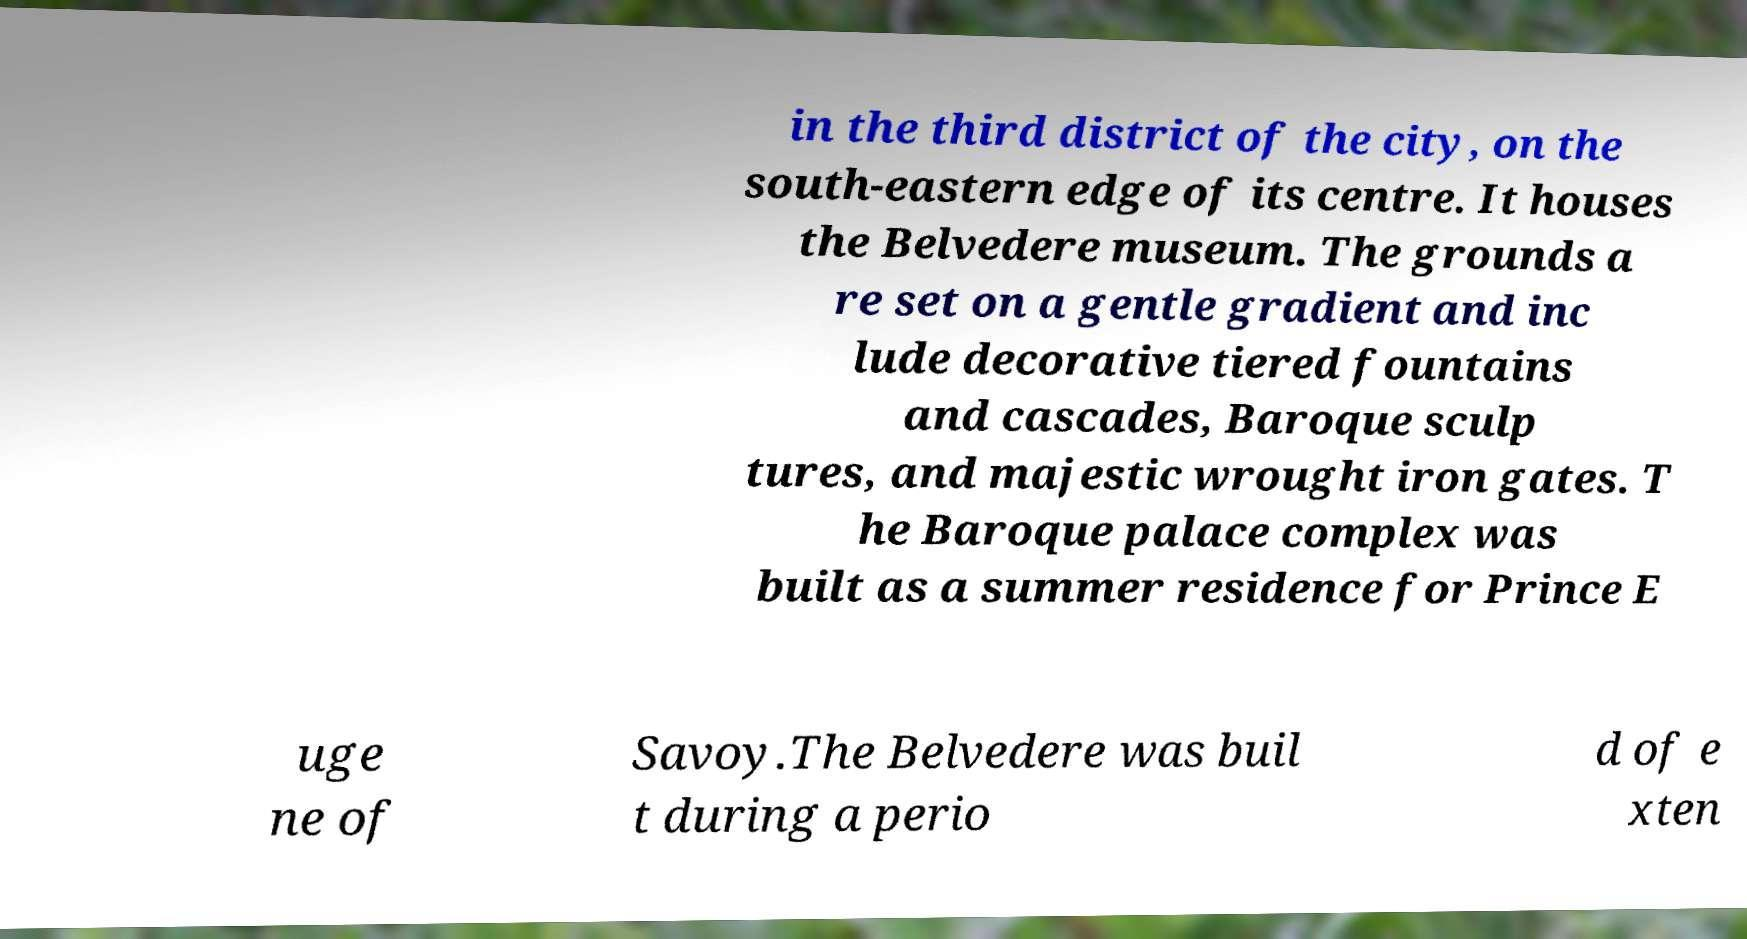There's text embedded in this image that I need extracted. Can you transcribe it verbatim? in the third district of the city, on the south-eastern edge of its centre. It houses the Belvedere museum. The grounds a re set on a gentle gradient and inc lude decorative tiered fountains and cascades, Baroque sculp tures, and majestic wrought iron gates. T he Baroque palace complex was built as a summer residence for Prince E uge ne of Savoy.The Belvedere was buil t during a perio d of e xten 